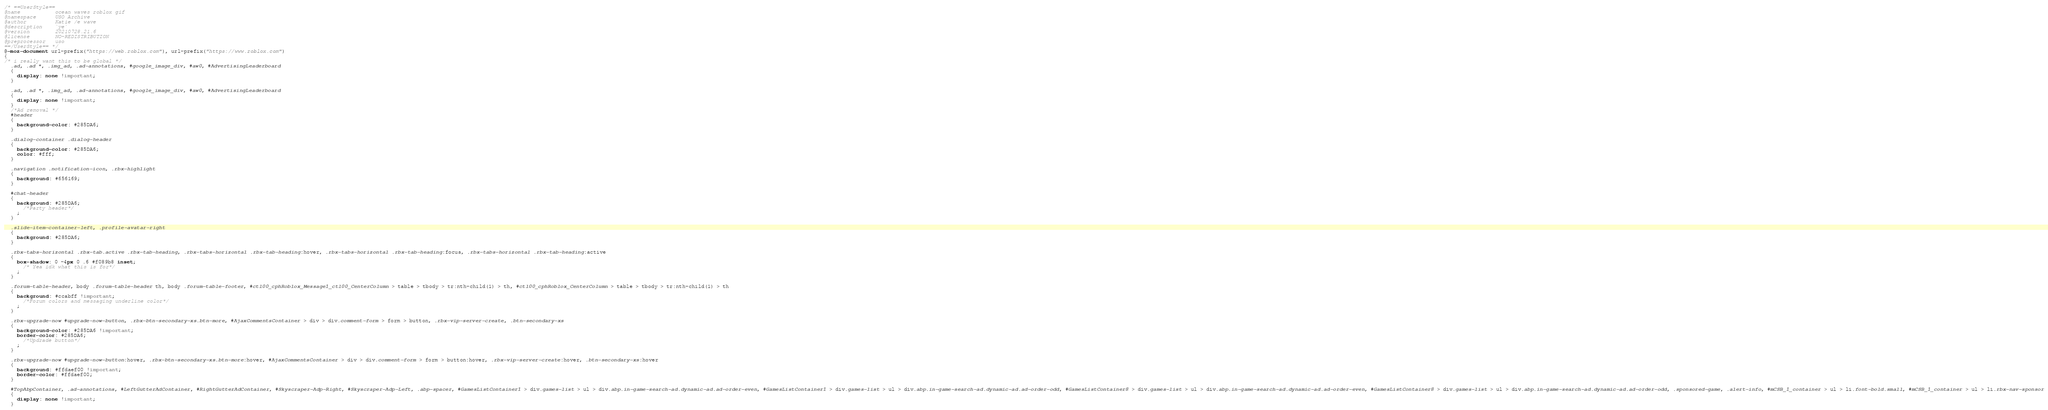Convert code to text. <code><loc_0><loc_0><loc_500><loc_500><_CSS_>/* ==UserStyle==
@name           ocean waves roblox gif
@namespace      USO Archive
@author         Katie /e wave
@description    `ye`
@version        20210728.21.6
@license        NO-REDISTRIBUTION
@preprocessor   uso
==/UserStyle== */
@-moz-document url-prefix("https://web.roblox.com"), url-prefix("https://www.roblox.com")
{
/* i really want this to be global */
  .ad, .ad *, .img_ad, .ad-annotations, #google_image_div, #aw0, #AdvertisingLeaderboard
  {
    display: none !important;
  }

  .ad, .ad *, .img_ad, .ad-annotations, #google_image_div, #aw0, #AdvertisingLeaderboard
  {
    display: none !important;
  }
  /*Ad removal */
  #header
  {
    background-color: #285DA6;
  }

  .dialog-container .dialog-header
  {
    background-color: #285DA6;
    color: #fff;
  }

  .navigation .notification-icon, .rbx-highlight
  {
    background: #656169;
  }

  #chat-header
  {
    background: #285DA6;
      /*Party header*/
    ;
  }

  .slide-item-container-left, .profile-avatar-right
  {
    background: #285DA6;
  }

  .rbx-tabs-horizontal .rbx-tab.active .rbx-tab-heading, .rbx-tabs-horizontal .rbx-tab-heading:hover, .rbx-tabs-horizontal .rbx-tab-heading:focus, .rbx-tabs-horizontal .rbx-tab-heading:active
  {
    box-shadow: 0 -4px 0 .6 #f089b8 inset;
      /* Yea idk what this is for*/
    ;
  }

  .forum-table-header, body .forum-table-header th, body .forum-table-footer, #ctl00_cphRoblox_Message1_ctl00_CenterColumn > table > tbody > tr:nth-child(1) > th, #ctl00_cphRoblox_CenterColumn > table > tbody > tr:nth-child(1) > th
  {
    background: #ccabff !important;
      /*Forum colors and messaging underline color*/
    ;
  }

  .rbx-upgrade-now #upgrade-now-button, .rbx-btn-secondary-xs.btn-more, #AjaxCommentsContainer > div > div.comment-form > form > button, .rbx-vip-server-create, .btn-secondary-xs
  {
    background-color: #285DA6 !important;
    border-color: #285DA6;
      /*Updrade button*/
    ;
  }

  .rbx-upgrade-now #upgrade-now-button:hover, .rbx-btn-secondary-xs.btn-more:hover, #AjaxCommentsContainer > div > div.comment-form > form > button:hover, .rbx-vip-server-create:hover, .btn-secondary-xs:hover
  {
    background: #ffdaef00 !important;
    border-color: #ffdaef00;
  }

  #TopAbpContainer, .ad-annotations, #LeftGutterAdContainer, #RightGutterAdContainer, #Skyscraper-Adp-Right, #Skyscraper-Adp-Left, .abp-spacer, #GamesListContainer1 > div.games-list > ul > div.abp.in-game-search-ad.dynamic-ad.ad-order-even, #GamesListContainer1 > div.games-list > ul > div.abp.in-game-search-ad.dynamic-ad.ad-order-odd, #GamesListContainer8 > div.games-list > ul > div.abp.in-game-search-ad.dynamic-ad.ad-order-even, #GamesListContainer8 > div.games-list > ul > div.abp.in-game-search-ad.dynamic-ad.ad-order-odd, .sponsored-game, .alert-info, #mCSB_1_container > ul > li.font-bold.small, #mCSB_1_container > ul > li.rbx-nav-sponsor
  {
    display: none !important;
  }
</code> 